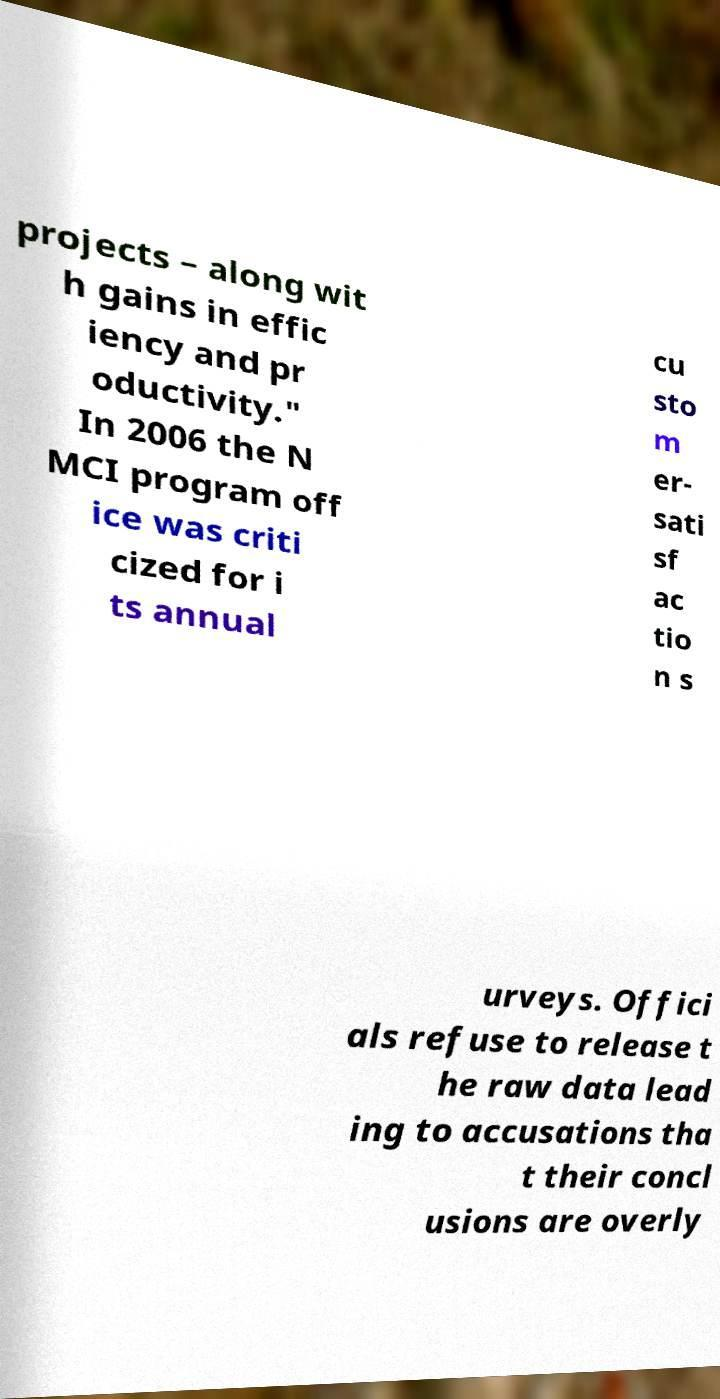There's text embedded in this image that I need extracted. Can you transcribe it verbatim? projects – along wit h gains in effic iency and pr oductivity." In 2006 the N MCI program off ice was criti cized for i ts annual cu sto m er- sati sf ac tio n s urveys. Offici als refuse to release t he raw data lead ing to accusations tha t their concl usions are overly 